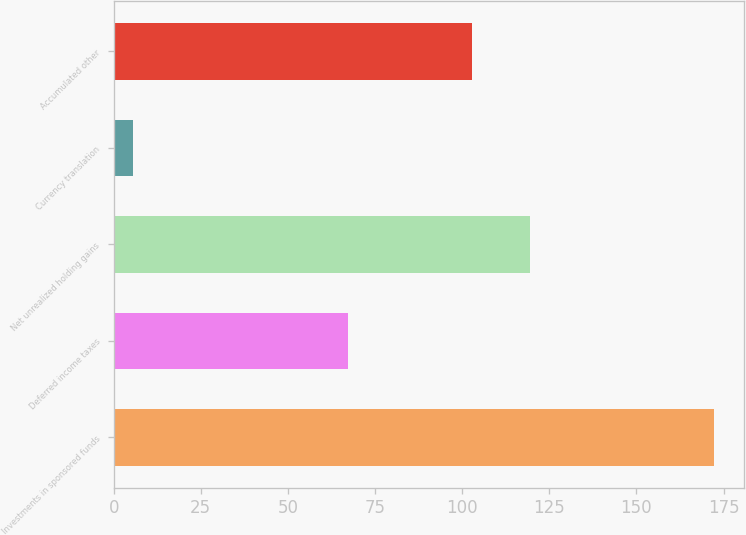Convert chart to OTSL. <chart><loc_0><loc_0><loc_500><loc_500><bar_chart><fcel>Investments in sponsored funds<fcel>Deferred income taxes<fcel>Net unrealized holding gains<fcel>Currency translation<fcel>Accumulated other<nl><fcel>172.2<fcel>67.3<fcel>119.46<fcel>5.6<fcel>102.8<nl></chart> 